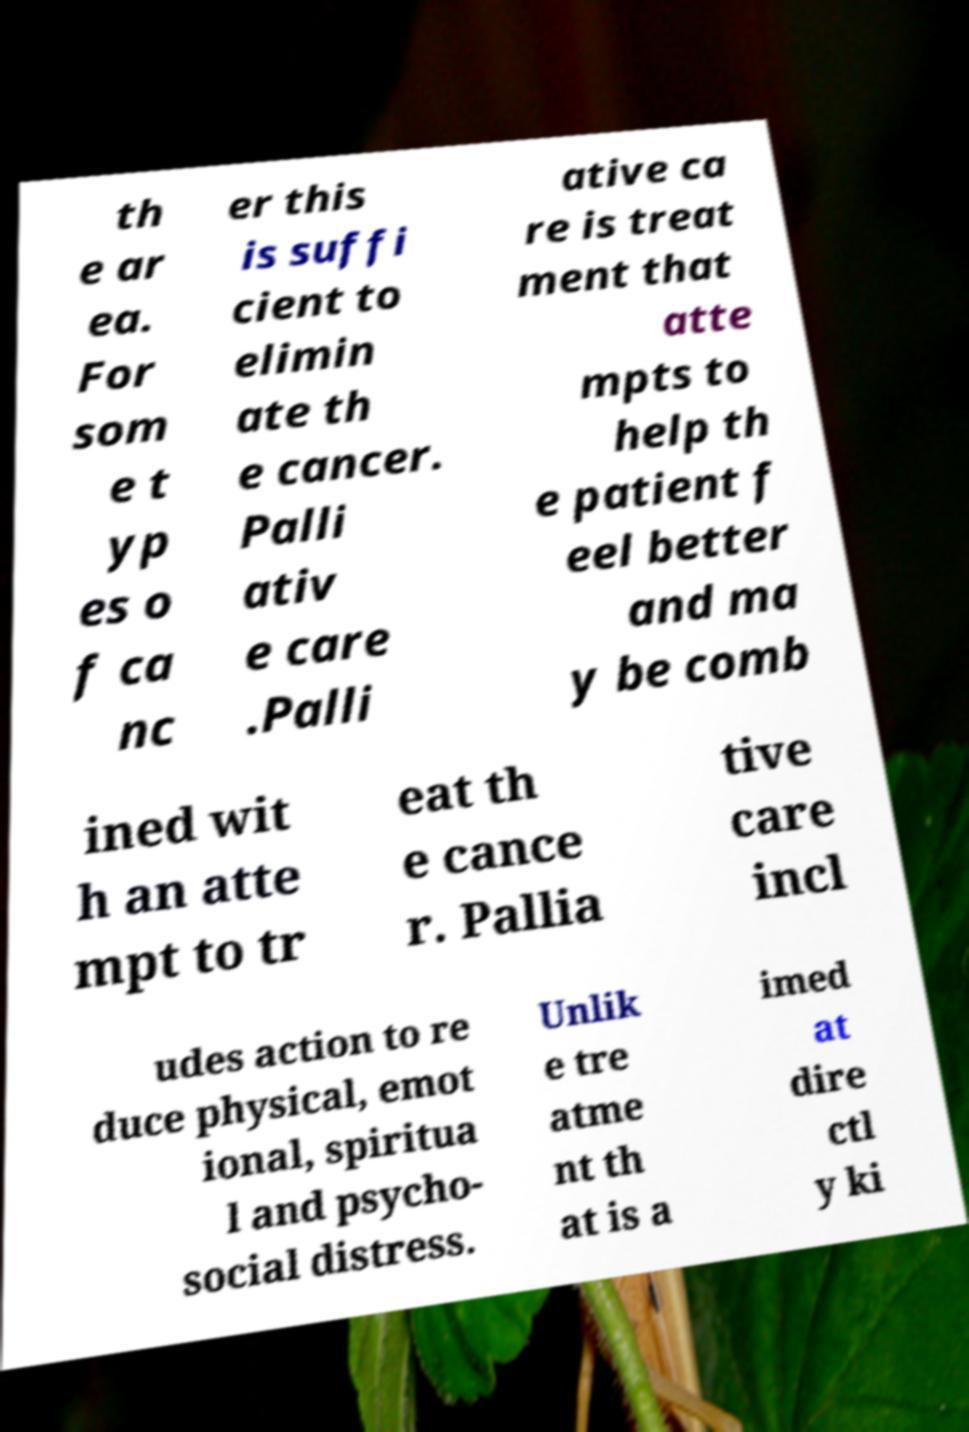Could you assist in decoding the text presented in this image and type it out clearly? th e ar ea. For som e t yp es o f ca nc er this is suffi cient to elimin ate th e cancer. Palli ativ e care .Palli ative ca re is treat ment that atte mpts to help th e patient f eel better and ma y be comb ined wit h an atte mpt to tr eat th e cance r. Pallia tive care incl udes action to re duce physical, emot ional, spiritua l and psycho- social distress. Unlik e tre atme nt th at is a imed at dire ctl y ki 